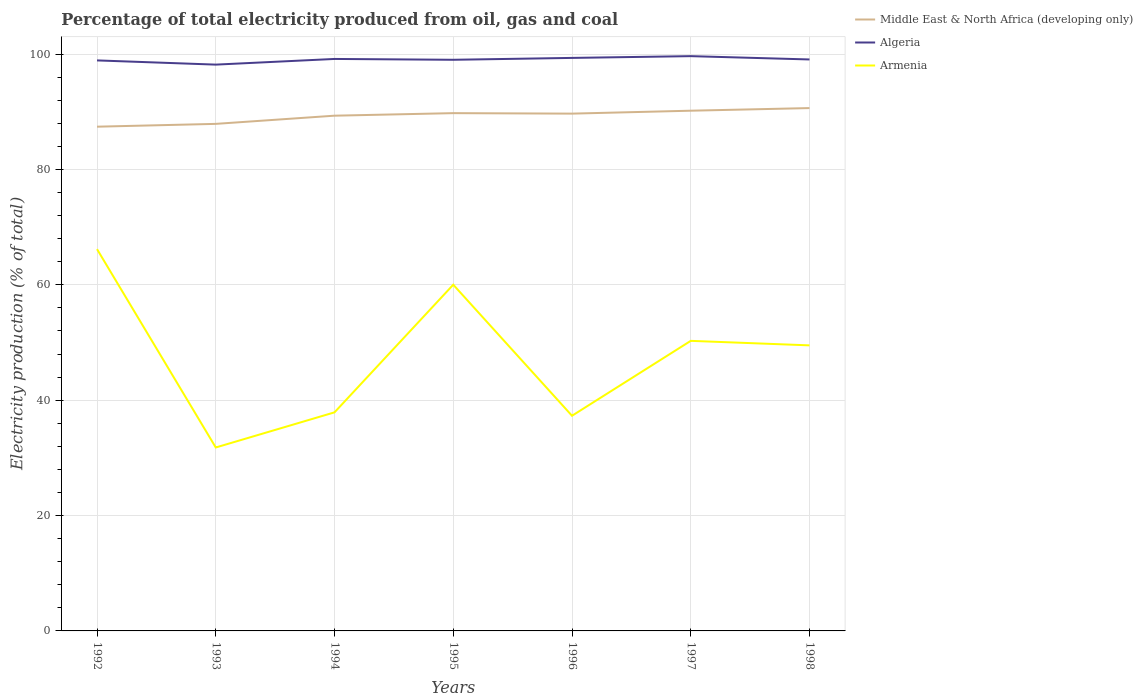Does the line corresponding to Middle East & North Africa (developing only) intersect with the line corresponding to Algeria?
Your answer should be compact. No. Is the number of lines equal to the number of legend labels?
Your answer should be compact. Yes. Across all years, what is the maximum electricity production in in Armenia?
Provide a short and direct response. 31.8. In which year was the electricity production in in Algeria maximum?
Provide a short and direct response. 1993. What is the total electricity production in in Armenia in the graph?
Make the answer very short. -22.13. What is the difference between the highest and the second highest electricity production in in Armenia?
Offer a terse response. 34.39. What is the difference between the highest and the lowest electricity production in in Algeria?
Offer a very short reply. 4. Is the electricity production in in Algeria strictly greater than the electricity production in in Armenia over the years?
Give a very brief answer. No. How many lines are there?
Offer a terse response. 3. How many years are there in the graph?
Your answer should be compact. 7. What is the difference between two consecutive major ticks on the Y-axis?
Give a very brief answer. 20. Are the values on the major ticks of Y-axis written in scientific E-notation?
Your response must be concise. No. How are the legend labels stacked?
Offer a very short reply. Vertical. What is the title of the graph?
Keep it short and to the point. Percentage of total electricity produced from oil, gas and coal. What is the label or title of the Y-axis?
Give a very brief answer. Electricity production (% of total). What is the Electricity production (% of total) of Middle East & North Africa (developing only) in 1992?
Provide a short and direct response. 87.42. What is the Electricity production (% of total) in Algeria in 1992?
Your response must be concise. 98.91. What is the Electricity production (% of total) of Armenia in 1992?
Your response must be concise. 66.19. What is the Electricity production (% of total) in Middle East & North Africa (developing only) in 1993?
Offer a very short reply. 87.91. What is the Electricity production (% of total) in Algeria in 1993?
Keep it short and to the point. 98.18. What is the Electricity production (% of total) in Armenia in 1993?
Your answer should be very brief. 31.8. What is the Electricity production (% of total) of Middle East & North Africa (developing only) in 1994?
Provide a short and direct response. 89.33. What is the Electricity production (% of total) of Algeria in 1994?
Provide a succinct answer. 99.17. What is the Electricity production (% of total) in Armenia in 1994?
Provide a succinct answer. 37.89. What is the Electricity production (% of total) of Middle East & North Africa (developing only) in 1995?
Provide a short and direct response. 89.77. What is the Electricity production (% of total) of Algeria in 1995?
Your answer should be compact. 99.02. What is the Electricity production (% of total) in Armenia in 1995?
Your response must be concise. 60.03. What is the Electricity production (% of total) of Middle East & North Africa (developing only) in 1996?
Offer a very short reply. 89.69. What is the Electricity production (% of total) in Algeria in 1996?
Your response must be concise. 99.35. What is the Electricity production (% of total) of Armenia in 1996?
Your answer should be very brief. 37.3. What is the Electricity production (% of total) in Middle East & North Africa (developing only) in 1997?
Your response must be concise. 90.19. What is the Electricity production (% of total) of Algeria in 1997?
Your answer should be very brief. 99.65. What is the Electricity production (% of total) in Armenia in 1997?
Provide a short and direct response. 50.29. What is the Electricity production (% of total) in Middle East & North Africa (developing only) in 1998?
Give a very brief answer. 90.65. What is the Electricity production (% of total) in Algeria in 1998?
Offer a terse response. 99.08. What is the Electricity production (% of total) in Armenia in 1998?
Provide a succinct answer. 49.51. Across all years, what is the maximum Electricity production (% of total) in Middle East & North Africa (developing only)?
Keep it short and to the point. 90.65. Across all years, what is the maximum Electricity production (% of total) in Algeria?
Offer a very short reply. 99.65. Across all years, what is the maximum Electricity production (% of total) of Armenia?
Your answer should be very brief. 66.19. Across all years, what is the minimum Electricity production (% of total) in Middle East & North Africa (developing only)?
Provide a succinct answer. 87.42. Across all years, what is the minimum Electricity production (% of total) of Algeria?
Your response must be concise. 98.18. Across all years, what is the minimum Electricity production (% of total) in Armenia?
Provide a short and direct response. 31.8. What is the total Electricity production (% of total) in Middle East & North Africa (developing only) in the graph?
Your answer should be compact. 624.95. What is the total Electricity production (% of total) of Algeria in the graph?
Your answer should be very brief. 693.35. What is the total Electricity production (% of total) in Armenia in the graph?
Keep it short and to the point. 333.01. What is the difference between the Electricity production (% of total) in Middle East & North Africa (developing only) in 1992 and that in 1993?
Your answer should be compact. -0.49. What is the difference between the Electricity production (% of total) in Algeria in 1992 and that in 1993?
Make the answer very short. 0.73. What is the difference between the Electricity production (% of total) in Armenia in 1992 and that in 1993?
Your answer should be compact. 34.39. What is the difference between the Electricity production (% of total) in Middle East & North Africa (developing only) in 1992 and that in 1994?
Provide a short and direct response. -1.91. What is the difference between the Electricity production (% of total) of Algeria in 1992 and that in 1994?
Provide a succinct answer. -0.25. What is the difference between the Electricity production (% of total) in Armenia in 1992 and that in 1994?
Your answer should be very brief. 28.3. What is the difference between the Electricity production (% of total) of Middle East & North Africa (developing only) in 1992 and that in 1995?
Provide a succinct answer. -2.35. What is the difference between the Electricity production (% of total) of Algeria in 1992 and that in 1995?
Give a very brief answer. -0.11. What is the difference between the Electricity production (% of total) of Armenia in 1992 and that in 1995?
Your answer should be compact. 6.17. What is the difference between the Electricity production (% of total) of Middle East & North Africa (developing only) in 1992 and that in 1996?
Offer a very short reply. -2.27. What is the difference between the Electricity production (% of total) of Algeria in 1992 and that in 1996?
Give a very brief answer. -0.43. What is the difference between the Electricity production (% of total) in Armenia in 1992 and that in 1996?
Offer a terse response. 28.89. What is the difference between the Electricity production (% of total) of Middle East & North Africa (developing only) in 1992 and that in 1997?
Provide a short and direct response. -2.77. What is the difference between the Electricity production (% of total) of Algeria in 1992 and that in 1997?
Give a very brief answer. -0.74. What is the difference between the Electricity production (% of total) in Armenia in 1992 and that in 1997?
Give a very brief answer. 15.9. What is the difference between the Electricity production (% of total) in Middle East & North Africa (developing only) in 1992 and that in 1998?
Your answer should be very brief. -3.23. What is the difference between the Electricity production (% of total) in Algeria in 1992 and that in 1998?
Your answer should be compact. -0.16. What is the difference between the Electricity production (% of total) of Armenia in 1992 and that in 1998?
Provide a succinct answer. 16.69. What is the difference between the Electricity production (% of total) in Middle East & North Africa (developing only) in 1993 and that in 1994?
Your answer should be compact. -1.42. What is the difference between the Electricity production (% of total) of Algeria in 1993 and that in 1994?
Give a very brief answer. -0.98. What is the difference between the Electricity production (% of total) in Armenia in 1993 and that in 1994?
Provide a succinct answer. -6.09. What is the difference between the Electricity production (% of total) of Middle East & North Africa (developing only) in 1993 and that in 1995?
Keep it short and to the point. -1.86. What is the difference between the Electricity production (% of total) in Algeria in 1993 and that in 1995?
Keep it short and to the point. -0.84. What is the difference between the Electricity production (% of total) of Armenia in 1993 and that in 1995?
Provide a succinct answer. -28.22. What is the difference between the Electricity production (% of total) of Middle East & North Africa (developing only) in 1993 and that in 1996?
Your answer should be compact. -1.78. What is the difference between the Electricity production (% of total) in Algeria in 1993 and that in 1996?
Offer a terse response. -1.16. What is the difference between the Electricity production (% of total) in Armenia in 1993 and that in 1996?
Your response must be concise. -5.5. What is the difference between the Electricity production (% of total) of Middle East & North Africa (developing only) in 1993 and that in 1997?
Your answer should be compact. -2.28. What is the difference between the Electricity production (% of total) in Algeria in 1993 and that in 1997?
Provide a short and direct response. -1.47. What is the difference between the Electricity production (% of total) in Armenia in 1993 and that in 1997?
Provide a short and direct response. -18.49. What is the difference between the Electricity production (% of total) in Middle East & North Africa (developing only) in 1993 and that in 1998?
Offer a very short reply. -2.74. What is the difference between the Electricity production (% of total) in Algeria in 1993 and that in 1998?
Your answer should be very brief. -0.89. What is the difference between the Electricity production (% of total) of Armenia in 1993 and that in 1998?
Offer a terse response. -17.7. What is the difference between the Electricity production (% of total) in Middle East & North Africa (developing only) in 1994 and that in 1995?
Your response must be concise. -0.44. What is the difference between the Electricity production (% of total) in Algeria in 1994 and that in 1995?
Provide a succinct answer. 0.14. What is the difference between the Electricity production (% of total) in Armenia in 1994 and that in 1995?
Your answer should be compact. -22.13. What is the difference between the Electricity production (% of total) of Middle East & North Africa (developing only) in 1994 and that in 1996?
Offer a terse response. -0.36. What is the difference between the Electricity production (% of total) of Algeria in 1994 and that in 1996?
Provide a short and direct response. -0.18. What is the difference between the Electricity production (% of total) of Armenia in 1994 and that in 1996?
Offer a very short reply. 0.59. What is the difference between the Electricity production (% of total) of Middle East & North Africa (developing only) in 1994 and that in 1997?
Provide a short and direct response. -0.86. What is the difference between the Electricity production (% of total) in Algeria in 1994 and that in 1997?
Make the answer very short. -0.49. What is the difference between the Electricity production (% of total) in Armenia in 1994 and that in 1997?
Provide a short and direct response. -12.4. What is the difference between the Electricity production (% of total) of Middle East & North Africa (developing only) in 1994 and that in 1998?
Offer a very short reply. -1.32. What is the difference between the Electricity production (% of total) in Algeria in 1994 and that in 1998?
Your response must be concise. 0.09. What is the difference between the Electricity production (% of total) of Armenia in 1994 and that in 1998?
Offer a terse response. -11.61. What is the difference between the Electricity production (% of total) of Middle East & North Africa (developing only) in 1995 and that in 1996?
Give a very brief answer. 0.08. What is the difference between the Electricity production (% of total) in Algeria in 1995 and that in 1996?
Offer a very short reply. -0.33. What is the difference between the Electricity production (% of total) in Armenia in 1995 and that in 1996?
Keep it short and to the point. 22.72. What is the difference between the Electricity production (% of total) of Middle East & North Africa (developing only) in 1995 and that in 1997?
Your answer should be compact. -0.42. What is the difference between the Electricity production (% of total) of Algeria in 1995 and that in 1997?
Your answer should be very brief. -0.63. What is the difference between the Electricity production (% of total) in Armenia in 1995 and that in 1997?
Provide a short and direct response. 9.73. What is the difference between the Electricity production (% of total) of Middle East & North Africa (developing only) in 1995 and that in 1998?
Offer a terse response. -0.88. What is the difference between the Electricity production (% of total) in Algeria in 1995 and that in 1998?
Your answer should be very brief. -0.05. What is the difference between the Electricity production (% of total) in Armenia in 1995 and that in 1998?
Make the answer very short. 10.52. What is the difference between the Electricity production (% of total) in Middle East & North Africa (developing only) in 1996 and that in 1997?
Your response must be concise. -0.51. What is the difference between the Electricity production (% of total) of Algeria in 1996 and that in 1997?
Offer a terse response. -0.3. What is the difference between the Electricity production (% of total) in Armenia in 1996 and that in 1997?
Provide a succinct answer. -12.99. What is the difference between the Electricity production (% of total) in Middle East & North Africa (developing only) in 1996 and that in 1998?
Give a very brief answer. -0.96. What is the difference between the Electricity production (% of total) of Algeria in 1996 and that in 1998?
Your response must be concise. 0.27. What is the difference between the Electricity production (% of total) of Armenia in 1996 and that in 1998?
Your response must be concise. -12.2. What is the difference between the Electricity production (% of total) in Middle East & North Africa (developing only) in 1997 and that in 1998?
Your answer should be compact. -0.46. What is the difference between the Electricity production (% of total) of Algeria in 1997 and that in 1998?
Your answer should be very brief. 0.58. What is the difference between the Electricity production (% of total) in Armenia in 1997 and that in 1998?
Ensure brevity in your answer.  0.78. What is the difference between the Electricity production (% of total) in Middle East & North Africa (developing only) in 1992 and the Electricity production (% of total) in Algeria in 1993?
Provide a succinct answer. -10.76. What is the difference between the Electricity production (% of total) in Middle East & North Africa (developing only) in 1992 and the Electricity production (% of total) in Armenia in 1993?
Make the answer very short. 55.62. What is the difference between the Electricity production (% of total) of Algeria in 1992 and the Electricity production (% of total) of Armenia in 1993?
Provide a succinct answer. 67.11. What is the difference between the Electricity production (% of total) of Middle East & North Africa (developing only) in 1992 and the Electricity production (% of total) of Algeria in 1994?
Offer a terse response. -11.75. What is the difference between the Electricity production (% of total) in Middle East & North Africa (developing only) in 1992 and the Electricity production (% of total) in Armenia in 1994?
Provide a short and direct response. 49.53. What is the difference between the Electricity production (% of total) of Algeria in 1992 and the Electricity production (% of total) of Armenia in 1994?
Your answer should be compact. 61.02. What is the difference between the Electricity production (% of total) in Middle East & North Africa (developing only) in 1992 and the Electricity production (% of total) in Algeria in 1995?
Keep it short and to the point. -11.6. What is the difference between the Electricity production (% of total) of Middle East & North Africa (developing only) in 1992 and the Electricity production (% of total) of Armenia in 1995?
Your answer should be compact. 27.39. What is the difference between the Electricity production (% of total) of Algeria in 1992 and the Electricity production (% of total) of Armenia in 1995?
Ensure brevity in your answer.  38.89. What is the difference between the Electricity production (% of total) of Middle East & North Africa (developing only) in 1992 and the Electricity production (% of total) of Algeria in 1996?
Offer a very short reply. -11.93. What is the difference between the Electricity production (% of total) of Middle East & North Africa (developing only) in 1992 and the Electricity production (% of total) of Armenia in 1996?
Ensure brevity in your answer.  50.12. What is the difference between the Electricity production (% of total) in Algeria in 1992 and the Electricity production (% of total) in Armenia in 1996?
Offer a very short reply. 61.61. What is the difference between the Electricity production (% of total) in Middle East & North Africa (developing only) in 1992 and the Electricity production (% of total) in Algeria in 1997?
Provide a succinct answer. -12.23. What is the difference between the Electricity production (% of total) in Middle East & North Africa (developing only) in 1992 and the Electricity production (% of total) in Armenia in 1997?
Make the answer very short. 37.13. What is the difference between the Electricity production (% of total) in Algeria in 1992 and the Electricity production (% of total) in Armenia in 1997?
Ensure brevity in your answer.  48.62. What is the difference between the Electricity production (% of total) in Middle East & North Africa (developing only) in 1992 and the Electricity production (% of total) in Algeria in 1998?
Keep it short and to the point. -11.66. What is the difference between the Electricity production (% of total) of Middle East & North Africa (developing only) in 1992 and the Electricity production (% of total) of Armenia in 1998?
Keep it short and to the point. 37.91. What is the difference between the Electricity production (% of total) of Algeria in 1992 and the Electricity production (% of total) of Armenia in 1998?
Make the answer very short. 49.4. What is the difference between the Electricity production (% of total) in Middle East & North Africa (developing only) in 1993 and the Electricity production (% of total) in Algeria in 1994?
Make the answer very short. -11.26. What is the difference between the Electricity production (% of total) of Middle East & North Africa (developing only) in 1993 and the Electricity production (% of total) of Armenia in 1994?
Provide a short and direct response. 50.02. What is the difference between the Electricity production (% of total) of Algeria in 1993 and the Electricity production (% of total) of Armenia in 1994?
Provide a succinct answer. 60.29. What is the difference between the Electricity production (% of total) of Middle East & North Africa (developing only) in 1993 and the Electricity production (% of total) of Algeria in 1995?
Ensure brevity in your answer.  -11.11. What is the difference between the Electricity production (% of total) of Middle East & North Africa (developing only) in 1993 and the Electricity production (% of total) of Armenia in 1995?
Offer a very short reply. 27.88. What is the difference between the Electricity production (% of total) in Algeria in 1993 and the Electricity production (% of total) in Armenia in 1995?
Your response must be concise. 38.16. What is the difference between the Electricity production (% of total) in Middle East & North Africa (developing only) in 1993 and the Electricity production (% of total) in Algeria in 1996?
Make the answer very short. -11.44. What is the difference between the Electricity production (% of total) in Middle East & North Africa (developing only) in 1993 and the Electricity production (% of total) in Armenia in 1996?
Offer a terse response. 50.61. What is the difference between the Electricity production (% of total) of Algeria in 1993 and the Electricity production (% of total) of Armenia in 1996?
Give a very brief answer. 60.88. What is the difference between the Electricity production (% of total) in Middle East & North Africa (developing only) in 1993 and the Electricity production (% of total) in Algeria in 1997?
Your answer should be compact. -11.74. What is the difference between the Electricity production (% of total) in Middle East & North Africa (developing only) in 1993 and the Electricity production (% of total) in Armenia in 1997?
Offer a very short reply. 37.62. What is the difference between the Electricity production (% of total) in Algeria in 1993 and the Electricity production (% of total) in Armenia in 1997?
Offer a terse response. 47.89. What is the difference between the Electricity production (% of total) of Middle East & North Africa (developing only) in 1993 and the Electricity production (% of total) of Algeria in 1998?
Ensure brevity in your answer.  -11.17. What is the difference between the Electricity production (% of total) of Middle East & North Africa (developing only) in 1993 and the Electricity production (% of total) of Armenia in 1998?
Give a very brief answer. 38.4. What is the difference between the Electricity production (% of total) in Algeria in 1993 and the Electricity production (% of total) in Armenia in 1998?
Offer a terse response. 48.67. What is the difference between the Electricity production (% of total) of Middle East & North Africa (developing only) in 1994 and the Electricity production (% of total) of Algeria in 1995?
Make the answer very short. -9.69. What is the difference between the Electricity production (% of total) of Middle East & North Africa (developing only) in 1994 and the Electricity production (% of total) of Armenia in 1995?
Provide a short and direct response. 29.3. What is the difference between the Electricity production (% of total) of Algeria in 1994 and the Electricity production (% of total) of Armenia in 1995?
Provide a succinct answer. 39.14. What is the difference between the Electricity production (% of total) of Middle East & North Africa (developing only) in 1994 and the Electricity production (% of total) of Algeria in 1996?
Provide a short and direct response. -10.02. What is the difference between the Electricity production (% of total) of Middle East & North Africa (developing only) in 1994 and the Electricity production (% of total) of Armenia in 1996?
Your answer should be very brief. 52.03. What is the difference between the Electricity production (% of total) of Algeria in 1994 and the Electricity production (% of total) of Armenia in 1996?
Offer a terse response. 61.86. What is the difference between the Electricity production (% of total) in Middle East & North Africa (developing only) in 1994 and the Electricity production (% of total) in Algeria in 1997?
Provide a short and direct response. -10.32. What is the difference between the Electricity production (% of total) of Middle East & North Africa (developing only) in 1994 and the Electricity production (% of total) of Armenia in 1997?
Your response must be concise. 39.04. What is the difference between the Electricity production (% of total) of Algeria in 1994 and the Electricity production (% of total) of Armenia in 1997?
Give a very brief answer. 48.87. What is the difference between the Electricity production (% of total) of Middle East & North Africa (developing only) in 1994 and the Electricity production (% of total) of Algeria in 1998?
Offer a very short reply. -9.75. What is the difference between the Electricity production (% of total) of Middle East & North Africa (developing only) in 1994 and the Electricity production (% of total) of Armenia in 1998?
Make the answer very short. 39.82. What is the difference between the Electricity production (% of total) in Algeria in 1994 and the Electricity production (% of total) in Armenia in 1998?
Make the answer very short. 49.66. What is the difference between the Electricity production (% of total) in Middle East & North Africa (developing only) in 1995 and the Electricity production (% of total) in Algeria in 1996?
Ensure brevity in your answer.  -9.58. What is the difference between the Electricity production (% of total) in Middle East & North Africa (developing only) in 1995 and the Electricity production (% of total) in Armenia in 1996?
Provide a short and direct response. 52.47. What is the difference between the Electricity production (% of total) of Algeria in 1995 and the Electricity production (% of total) of Armenia in 1996?
Provide a short and direct response. 61.72. What is the difference between the Electricity production (% of total) of Middle East & North Africa (developing only) in 1995 and the Electricity production (% of total) of Algeria in 1997?
Provide a short and direct response. -9.88. What is the difference between the Electricity production (% of total) in Middle East & North Africa (developing only) in 1995 and the Electricity production (% of total) in Armenia in 1997?
Your response must be concise. 39.48. What is the difference between the Electricity production (% of total) of Algeria in 1995 and the Electricity production (% of total) of Armenia in 1997?
Offer a terse response. 48.73. What is the difference between the Electricity production (% of total) in Middle East & North Africa (developing only) in 1995 and the Electricity production (% of total) in Algeria in 1998?
Make the answer very short. -9.31. What is the difference between the Electricity production (% of total) of Middle East & North Africa (developing only) in 1995 and the Electricity production (% of total) of Armenia in 1998?
Provide a short and direct response. 40.26. What is the difference between the Electricity production (% of total) in Algeria in 1995 and the Electricity production (% of total) in Armenia in 1998?
Provide a short and direct response. 49.51. What is the difference between the Electricity production (% of total) in Middle East & North Africa (developing only) in 1996 and the Electricity production (% of total) in Algeria in 1997?
Offer a very short reply. -9.97. What is the difference between the Electricity production (% of total) in Middle East & North Africa (developing only) in 1996 and the Electricity production (% of total) in Armenia in 1997?
Your answer should be very brief. 39.4. What is the difference between the Electricity production (% of total) of Algeria in 1996 and the Electricity production (% of total) of Armenia in 1997?
Make the answer very short. 49.06. What is the difference between the Electricity production (% of total) in Middle East & North Africa (developing only) in 1996 and the Electricity production (% of total) in Algeria in 1998?
Your answer should be compact. -9.39. What is the difference between the Electricity production (% of total) in Middle East & North Africa (developing only) in 1996 and the Electricity production (% of total) in Armenia in 1998?
Offer a very short reply. 40.18. What is the difference between the Electricity production (% of total) in Algeria in 1996 and the Electricity production (% of total) in Armenia in 1998?
Provide a succinct answer. 49.84. What is the difference between the Electricity production (% of total) in Middle East & North Africa (developing only) in 1997 and the Electricity production (% of total) in Algeria in 1998?
Provide a short and direct response. -8.88. What is the difference between the Electricity production (% of total) in Middle East & North Africa (developing only) in 1997 and the Electricity production (% of total) in Armenia in 1998?
Your answer should be very brief. 40.68. What is the difference between the Electricity production (% of total) in Algeria in 1997 and the Electricity production (% of total) in Armenia in 1998?
Offer a very short reply. 50.14. What is the average Electricity production (% of total) of Middle East & North Africa (developing only) per year?
Your answer should be very brief. 89.28. What is the average Electricity production (% of total) of Algeria per year?
Your response must be concise. 99.05. What is the average Electricity production (% of total) of Armenia per year?
Your answer should be very brief. 47.57. In the year 1992, what is the difference between the Electricity production (% of total) of Middle East & North Africa (developing only) and Electricity production (% of total) of Algeria?
Your answer should be compact. -11.49. In the year 1992, what is the difference between the Electricity production (% of total) of Middle East & North Africa (developing only) and Electricity production (% of total) of Armenia?
Your answer should be very brief. 21.23. In the year 1992, what is the difference between the Electricity production (% of total) in Algeria and Electricity production (% of total) in Armenia?
Your answer should be very brief. 32.72. In the year 1993, what is the difference between the Electricity production (% of total) in Middle East & North Africa (developing only) and Electricity production (% of total) in Algeria?
Your response must be concise. -10.27. In the year 1993, what is the difference between the Electricity production (% of total) of Middle East & North Africa (developing only) and Electricity production (% of total) of Armenia?
Offer a very short reply. 56.11. In the year 1993, what is the difference between the Electricity production (% of total) of Algeria and Electricity production (% of total) of Armenia?
Your answer should be compact. 66.38. In the year 1994, what is the difference between the Electricity production (% of total) of Middle East & North Africa (developing only) and Electricity production (% of total) of Algeria?
Give a very brief answer. -9.84. In the year 1994, what is the difference between the Electricity production (% of total) in Middle East & North Africa (developing only) and Electricity production (% of total) in Armenia?
Make the answer very short. 51.44. In the year 1994, what is the difference between the Electricity production (% of total) of Algeria and Electricity production (% of total) of Armenia?
Your response must be concise. 61.27. In the year 1995, what is the difference between the Electricity production (% of total) of Middle East & North Africa (developing only) and Electricity production (% of total) of Algeria?
Provide a short and direct response. -9.25. In the year 1995, what is the difference between the Electricity production (% of total) of Middle East & North Africa (developing only) and Electricity production (% of total) of Armenia?
Your response must be concise. 29.74. In the year 1995, what is the difference between the Electricity production (% of total) in Algeria and Electricity production (% of total) in Armenia?
Provide a short and direct response. 39. In the year 1996, what is the difference between the Electricity production (% of total) in Middle East & North Africa (developing only) and Electricity production (% of total) in Algeria?
Your answer should be compact. -9.66. In the year 1996, what is the difference between the Electricity production (% of total) of Middle East & North Africa (developing only) and Electricity production (% of total) of Armenia?
Make the answer very short. 52.38. In the year 1996, what is the difference between the Electricity production (% of total) in Algeria and Electricity production (% of total) in Armenia?
Your response must be concise. 62.04. In the year 1997, what is the difference between the Electricity production (% of total) in Middle East & North Africa (developing only) and Electricity production (% of total) in Algeria?
Your answer should be very brief. -9.46. In the year 1997, what is the difference between the Electricity production (% of total) of Middle East & North Africa (developing only) and Electricity production (% of total) of Armenia?
Your response must be concise. 39.9. In the year 1997, what is the difference between the Electricity production (% of total) of Algeria and Electricity production (% of total) of Armenia?
Ensure brevity in your answer.  49.36. In the year 1998, what is the difference between the Electricity production (% of total) of Middle East & North Africa (developing only) and Electricity production (% of total) of Algeria?
Offer a very short reply. -8.43. In the year 1998, what is the difference between the Electricity production (% of total) of Middle East & North Africa (developing only) and Electricity production (% of total) of Armenia?
Offer a very short reply. 41.14. In the year 1998, what is the difference between the Electricity production (% of total) of Algeria and Electricity production (% of total) of Armenia?
Ensure brevity in your answer.  49.57. What is the ratio of the Electricity production (% of total) in Algeria in 1992 to that in 1993?
Offer a terse response. 1.01. What is the ratio of the Electricity production (% of total) in Armenia in 1992 to that in 1993?
Offer a terse response. 2.08. What is the ratio of the Electricity production (% of total) of Middle East & North Africa (developing only) in 1992 to that in 1994?
Make the answer very short. 0.98. What is the ratio of the Electricity production (% of total) of Algeria in 1992 to that in 1994?
Your answer should be compact. 1. What is the ratio of the Electricity production (% of total) of Armenia in 1992 to that in 1994?
Keep it short and to the point. 1.75. What is the ratio of the Electricity production (% of total) of Middle East & North Africa (developing only) in 1992 to that in 1995?
Your response must be concise. 0.97. What is the ratio of the Electricity production (% of total) in Algeria in 1992 to that in 1995?
Provide a short and direct response. 1. What is the ratio of the Electricity production (% of total) in Armenia in 1992 to that in 1995?
Your answer should be very brief. 1.1. What is the ratio of the Electricity production (% of total) of Middle East & North Africa (developing only) in 1992 to that in 1996?
Your answer should be compact. 0.97. What is the ratio of the Electricity production (% of total) in Armenia in 1992 to that in 1996?
Your response must be concise. 1.77. What is the ratio of the Electricity production (% of total) in Middle East & North Africa (developing only) in 1992 to that in 1997?
Make the answer very short. 0.97. What is the ratio of the Electricity production (% of total) in Algeria in 1992 to that in 1997?
Offer a terse response. 0.99. What is the ratio of the Electricity production (% of total) in Armenia in 1992 to that in 1997?
Provide a succinct answer. 1.32. What is the ratio of the Electricity production (% of total) of Middle East & North Africa (developing only) in 1992 to that in 1998?
Keep it short and to the point. 0.96. What is the ratio of the Electricity production (% of total) of Algeria in 1992 to that in 1998?
Give a very brief answer. 1. What is the ratio of the Electricity production (% of total) in Armenia in 1992 to that in 1998?
Give a very brief answer. 1.34. What is the ratio of the Electricity production (% of total) in Middle East & North Africa (developing only) in 1993 to that in 1994?
Ensure brevity in your answer.  0.98. What is the ratio of the Electricity production (% of total) in Algeria in 1993 to that in 1994?
Provide a succinct answer. 0.99. What is the ratio of the Electricity production (% of total) of Armenia in 1993 to that in 1994?
Give a very brief answer. 0.84. What is the ratio of the Electricity production (% of total) of Middle East & North Africa (developing only) in 1993 to that in 1995?
Give a very brief answer. 0.98. What is the ratio of the Electricity production (% of total) in Algeria in 1993 to that in 1995?
Offer a very short reply. 0.99. What is the ratio of the Electricity production (% of total) of Armenia in 1993 to that in 1995?
Your response must be concise. 0.53. What is the ratio of the Electricity production (% of total) in Middle East & North Africa (developing only) in 1993 to that in 1996?
Your response must be concise. 0.98. What is the ratio of the Electricity production (% of total) of Algeria in 1993 to that in 1996?
Offer a terse response. 0.99. What is the ratio of the Electricity production (% of total) of Armenia in 1993 to that in 1996?
Keep it short and to the point. 0.85. What is the ratio of the Electricity production (% of total) in Middle East & North Africa (developing only) in 1993 to that in 1997?
Ensure brevity in your answer.  0.97. What is the ratio of the Electricity production (% of total) in Algeria in 1993 to that in 1997?
Make the answer very short. 0.99. What is the ratio of the Electricity production (% of total) in Armenia in 1993 to that in 1997?
Offer a very short reply. 0.63. What is the ratio of the Electricity production (% of total) of Middle East & North Africa (developing only) in 1993 to that in 1998?
Make the answer very short. 0.97. What is the ratio of the Electricity production (% of total) of Armenia in 1993 to that in 1998?
Give a very brief answer. 0.64. What is the ratio of the Electricity production (% of total) in Middle East & North Africa (developing only) in 1994 to that in 1995?
Offer a very short reply. 1. What is the ratio of the Electricity production (% of total) in Algeria in 1994 to that in 1995?
Your answer should be very brief. 1. What is the ratio of the Electricity production (% of total) of Armenia in 1994 to that in 1995?
Give a very brief answer. 0.63. What is the ratio of the Electricity production (% of total) in Algeria in 1994 to that in 1996?
Make the answer very short. 1. What is the ratio of the Electricity production (% of total) in Armenia in 1994 to that in 1996?
Offer a very short reply. 1.02. What is the ratio of the Electricity production (% of total) of Middle East & North Africa (developing only) in 1994 to that in 1997?
Provide a short and direct response. 0.99. What is the ratio of the Electricity production (% of total) in Armenia in 1994 to that in 1997?
Give a very brief answer. 0.75. What is the ratio of the Electricity production (% of total) in Middle East & North Africa (developing only) in 1994 to that in 1998?
Provide a short and direct response. 0.99. What is the ratio of the Electricity production (% of total) of Armenia in 1994 to that in 1998?
Your answer should be compact. 0.77. What is the ratio of the Electricity production (% of total) of Middle East & North Africa (developing only) in 1995 to that in 1996?
Keep it short and to the point. 1. What is the ratio of the Electricity production (% of total) in Armenia in 1995 to that in 1996?
Provide a succinct answer. 1.61. What is the ratio of the Electricity production (% of total) in Middle East & North Africa (developing only) in 1995 to that in 1997?
Your answer should be very brief. 1. What is the ratio of the Electricity production (% of total) in Algeria in 1995 to that in 1997?
Offer a very short reply. 0.99. What is the ratio of the Electricity production (% of total) in Armenia in 1995 to that in 1997?
Make the answer very short. 1.19. What is the ratio of the Electricity production (% of total) in Middle East & North Africa (developing only) in 1995 to that in 1998?
Your response must be concise. 0.99. What is the ratio of the Electricity production (% of total) in Algeria in 1995 to that in 1998?
Ensure brevity in your answer.  1. What is the ratio of the Electricity production (% of total) in Armenia in 1995 to that in 1998?
Ensure brevity in your answer.  1.21. What is the ratio of the Electricity production (% of total) of Algeria in 1996 to that in 1997?
Provide a short and direct response. 1. What is the ratio of the Electricity production (% of total) of Armenia in 1996 to that in 1997?
Offer a terse response. 0.74. What is the ratio of the Electricity production (% of total) of Algeria in 1996 to that in 1998?
Offer a very short reply. 1. What is the ratio of the Electricity production (% of total) in Armenia in 1996 to that in 1998?
Provide a succinct answer. 0.75. What is the ratio of the Electricity production (% of total) of Armenia in 1997 to that in 1998?
Your answer should be very brief. 1.02. What is the difference between the highest and the second highest Electricity production (% of total) in Middle East & North Africa (developing only)?
Ensure brevity in your answer.  0.46. What is the difference between the highest and the second highest Electricity production (% of total) in Algeria?
Your answer should be very brief. 0.3. What is the difference between the highest and the second highest Electricity production (% of total) in Armenia?
Your answer should be compact. 6.17. What is the difference between the highest and the lowest Electricity production (% of total) of Middle East & North Africa (developing only)?
Provide a short and direct response. 3.23. What is the difference between the highest and the lowest Electricity production (% of total) of Algeria?
Provide a short and direct response. 1.47. What is the difference between the highest and the lowest Electricity production (% of total) of Armenia?
Your answer should be very brief. 34.39. 